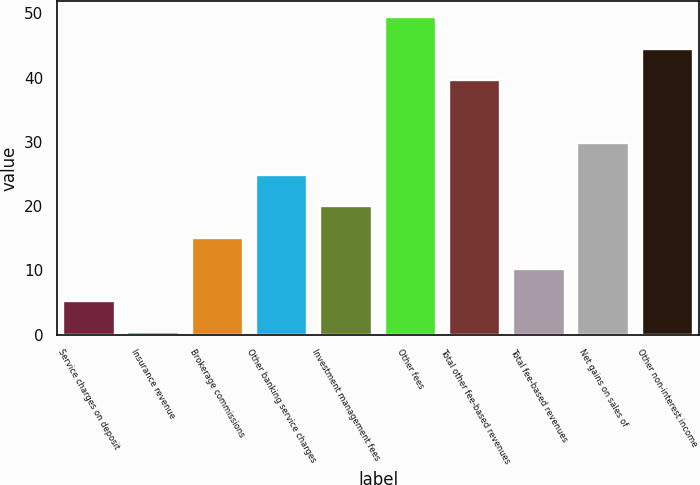Convert chart to OTSL. <chart><loc_0><loc_0><loc_500><loc_500><bar_chart><fcel>Service charges on deposit<fcel>Insurance revenue<fcel>Brokerage commissions<fcel>Other banking service charges<fcel>Investment management fees<fcel>Other fees<fcel>Total other fee-based revenues<fcel>Total fee-based revenues<fcel>Net gains on sales of<fcel>Other non-interest income<nl><fcel>5.3<fcel>0.4<fcel>15.1<fcel>24.9<fcel>20<fcel>49.4<fcel>39.6<fcel>10.2<fcel>29.8<fcel>44.5<nl></chart> 